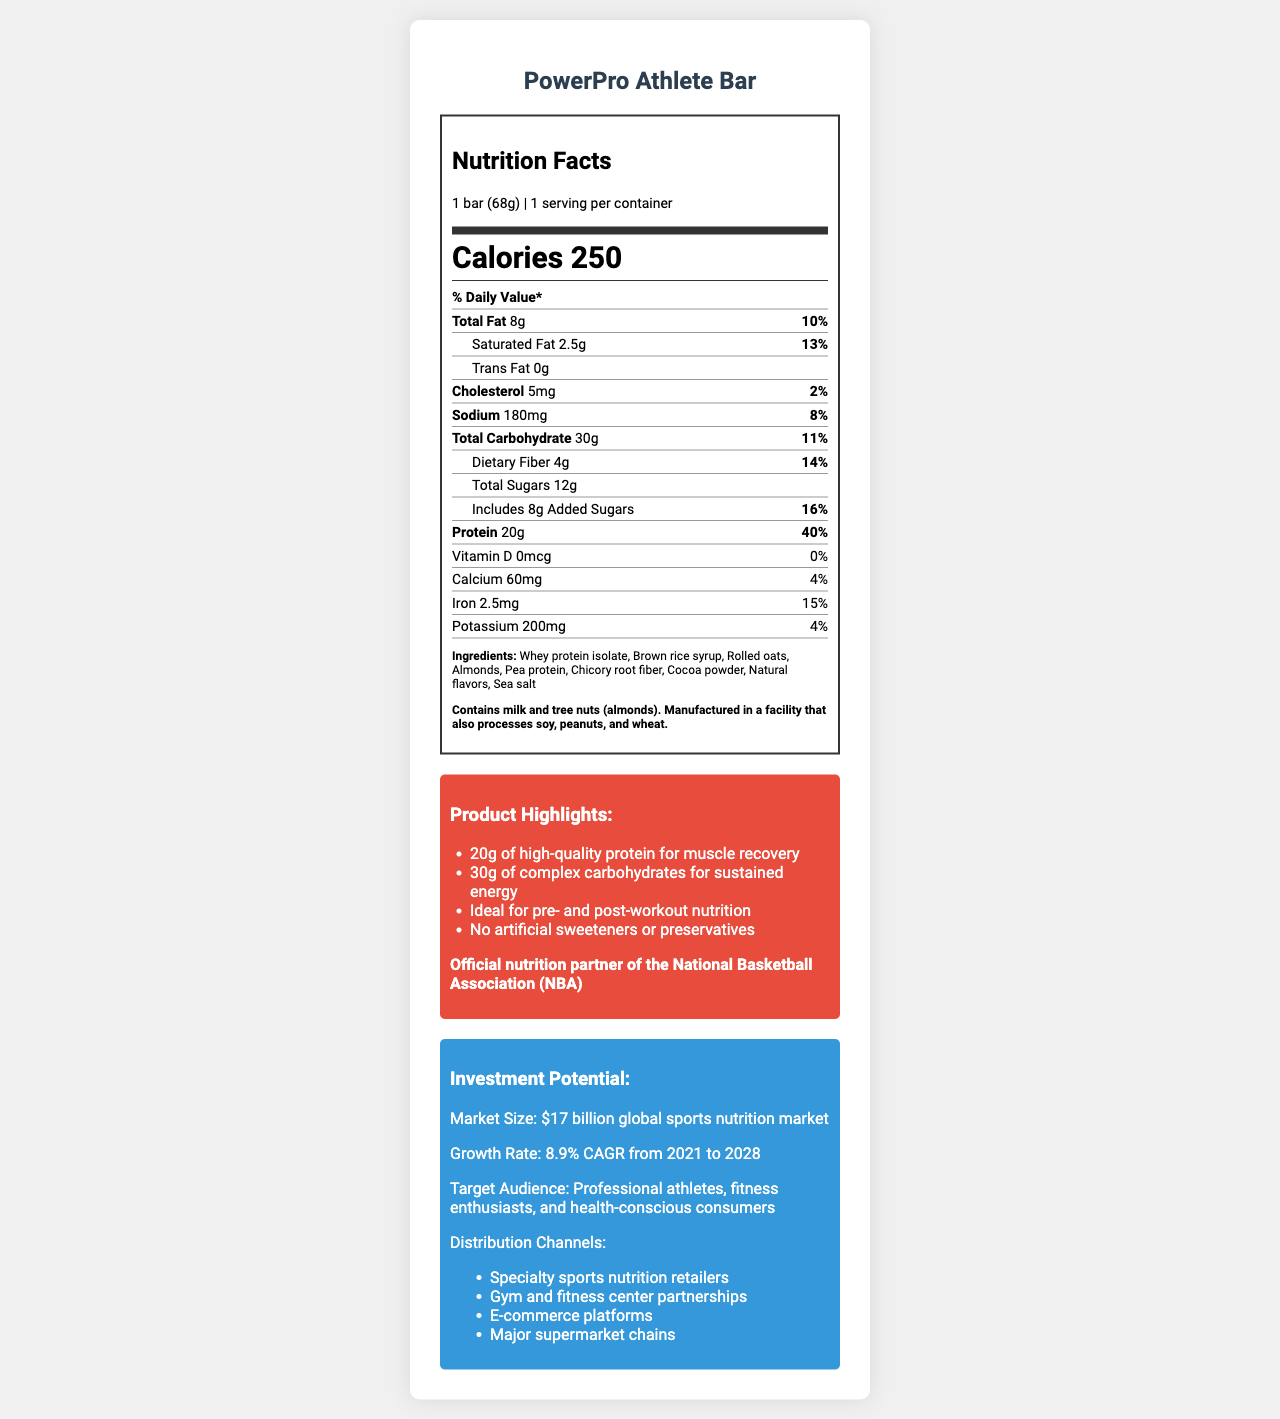what is the serving size of the PowerPro Athlete Bar? The serving size is specified at the top of the nutrition label under the heading "serving size".
Answer: 1 bar (68g) how many calories are in one serving of the PowerPro Athlete Bar? The number of calories per serving is listed under the heading "Calories" in the nutrition facts.
Answer: 250 what is the total carbohydrate content per serving? The total carbohydrate content per serving is shown under the "Total Carbohydrate" section of the nutrition label.
Answer: 30g what is the protein content per serving, and what percentage of the daily value does this represent? The protein content per serving is 20g, and it represents 40% of the daily value as shown in the protein section of the nutrition label.
Answer: 20g, 40% could this energy bar be suitable for athletes needing high protein intake? The bar contains 20g of protein, which is 40% of the daily value, making it suitable for athletes needing high protein intake.
Answer: Yes which of the following is a marketing claim made about the PowerPro Athlete Bar? A. Contains artificial sweeteners B. Supports heart health C. Ideal for pre- and post-workout nutrition D. Low in calories Among the claims listed under "Product Highlights", it states that the bar is "Ideal for pre- and post-workout nutrition".
Answer: C how much sodium does the PowerPro Athlete Bar contain per serving? A. 150mg B. 180mg C. 200mg D. 220mg The sodium content per serving is 180mg as shown in the nutrition facts label.
Answer: B which of the following distribution channels is NOT mentioned for the PowerPro Athlete Bar? A. Specialty sports nutrition retailers B. Gym and fitness center partnerships C. University campus stores D. E-commerce platforms The mentioned distribution channels include specialty sports nutrition retailers, gym and fitness center partnerships, e-commerce platforms, and major supermarket chains, but not university campus stores.
Answer: C does the PowerPro Athlete Bar contain any trans fat? The nutrition label states that the amount of trans fat is "0g".
Answer: No summarize the key points highlighted in the document about the PowerPro Athlete Bar. The document provides detailed nutrition facts, ingredients, allergen information, marketing claims, endorsement details, and investment potential information about the PowerPro Athlete Bar, making it appealing to athletes and investors alike.
Answer: The PowerPro Athlete Bar is a high-protein energy bar designed for athletes, offering 20g of protein and 30g of carbohydrates per serving. It is marketed for muscle recovery and sustained energy, making it ideal for pre- and post-workout nutrition. The bar contains no artificial sweeteners or preservatives and is endorsed by the NBA. The sports nutrition market is growing, targeting professional athletes, fitness enthusiasts, and health-conscious consumers through various distribution channels. what specific allergens are present in the PowerPro Athlete Bar? The allergen information section specifies that the bar contains milk and tree nuts (almonds).
Answer: Milk and tree nuts (almonds) what is the market size for the global sports nutrition market? The investment potential section mentions the market size as $17 billion.
Answer: $17 billion does the PowerPro Athlete Bar provide any vitamin D? The nutrition label indicates "0mcg" for vitamin D and shows "0%" for the daily value.
Answer: No describe the protein content of this bar in terms of its benefits for muscle recovery. The marketing claims specifically mention "20g of high-quality protein for muscle recovery".
Answer: The bar contains 20g of high-quality protein per serving, which supports muscle recovery as highlighted in the marketing claims. how many grams of dietary fiber are in one serving of the PowerPro Athlete Bar? The dietary fiber content is listed as 4g per serving on the nutrition label.
Answer: 4g can we determine the price of the PowerPro Athlete Bar from this document? The document does not provide any information about the price of the PowerPro Athlete Bar.
Answer: Not enough information 